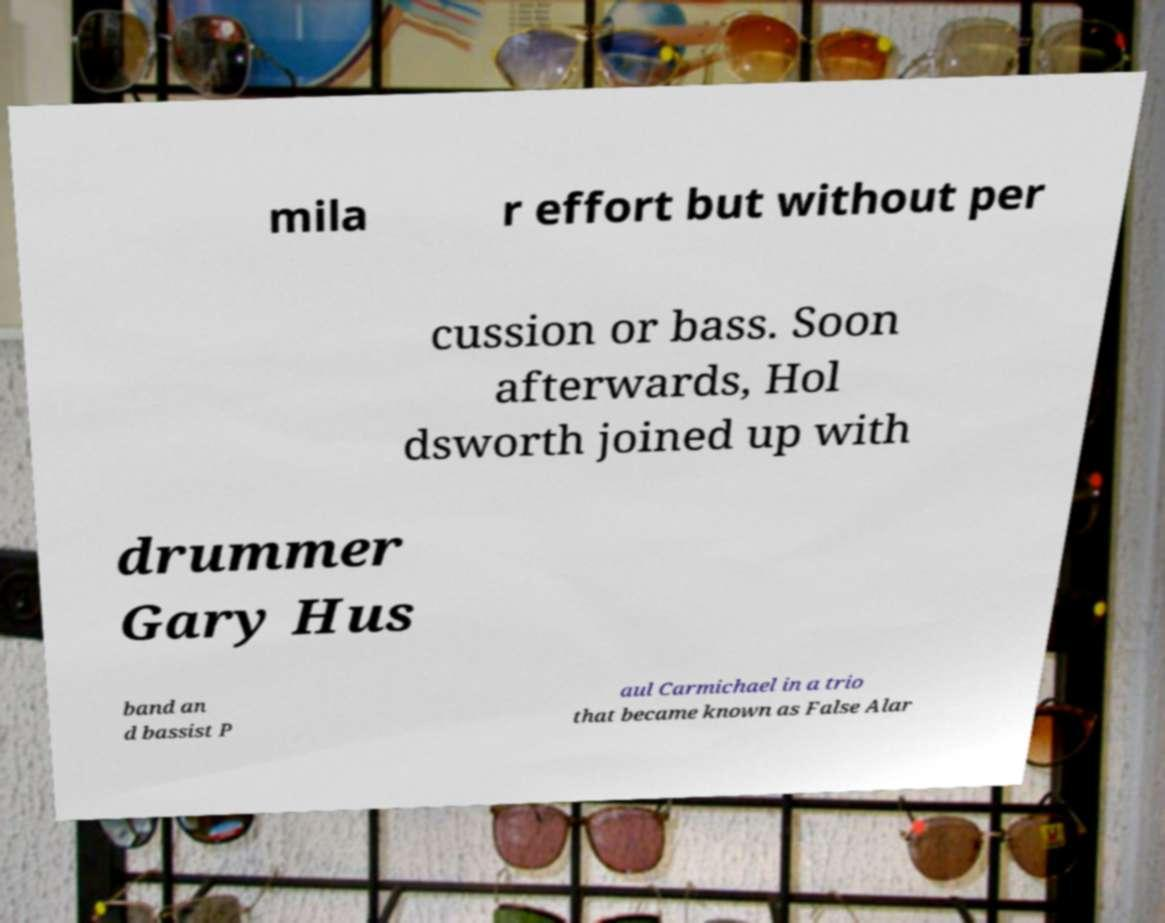Can you accurately transcribe the text from the provided image for me? mila r effort but without per cussion or bass. Soon afterwards, Hol dsworth joined up with drummer Gary Hus band an d bassist P aul Carmichael in a trio that became known as False Alar 